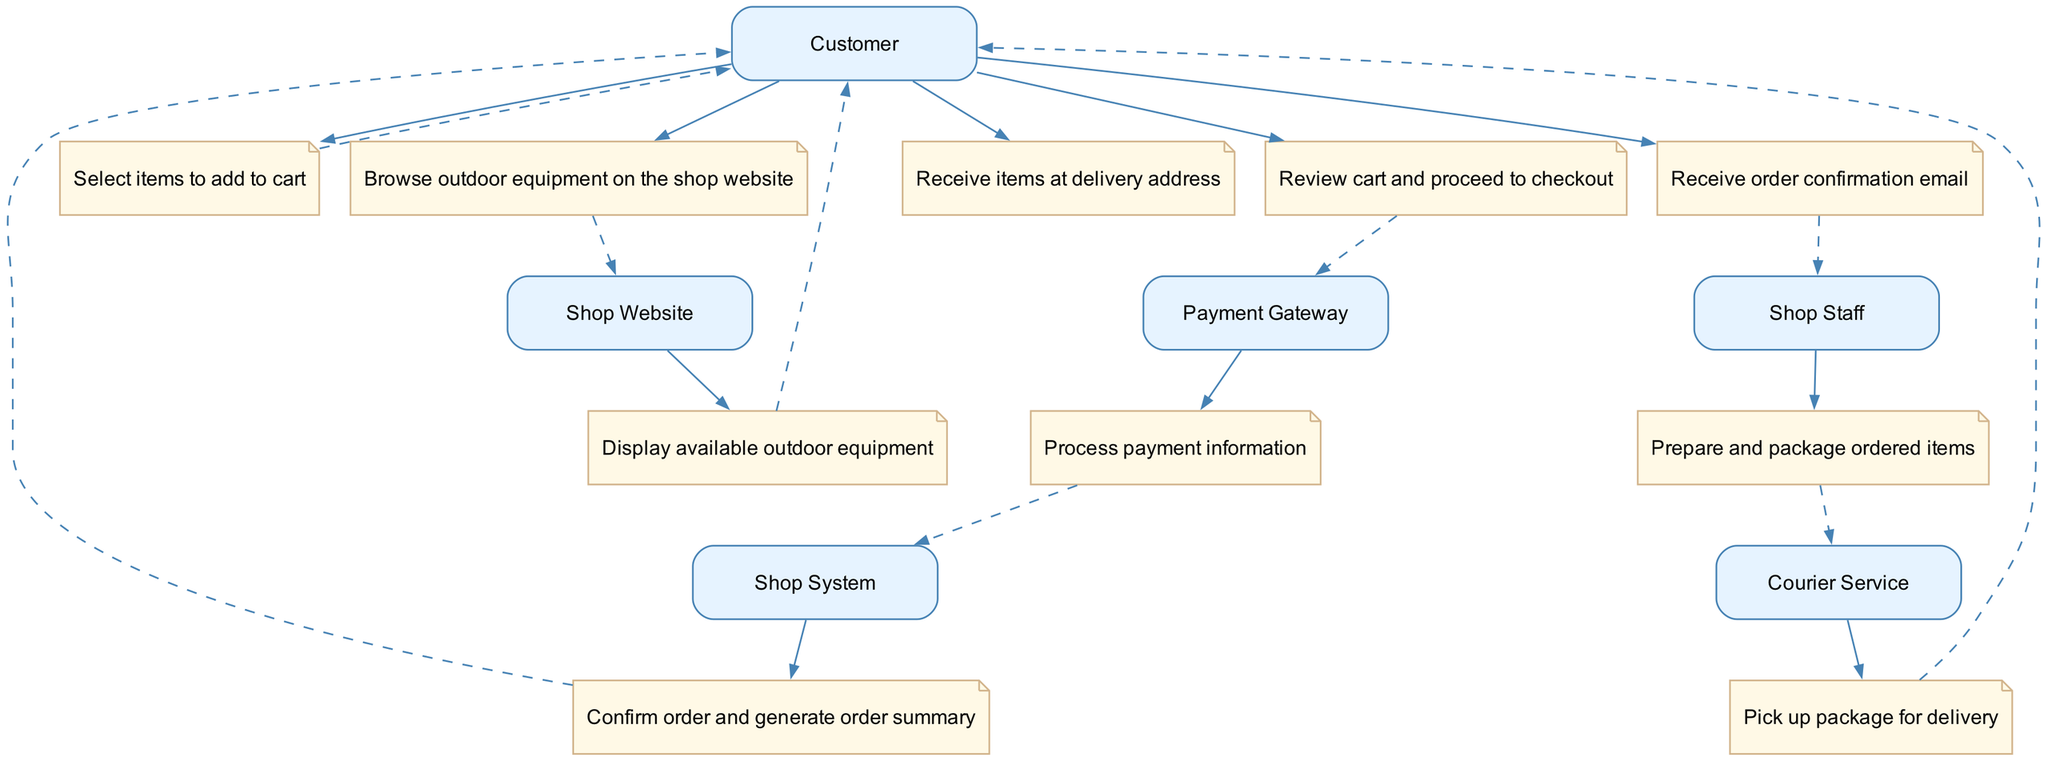What is the first action taken by the customer? The first action listed in the sequence diagram is "Browse outdoor equipment on the shop website," which indicates the initiation of the customer interaction with the shop's online platform.
Answer: Browse outdoor equipment on the shop website How many actors are involved in the process? By analyzing the diagram, I can see that there are five distinct actors: Customer, Shop Website, Payment Gateway, Shop Staff, and Courier Service. Therefore, the total number of actors is five.
Answer: Five What action does the shop system take after payment is processed? According to the sequence of actions, after the payment information is processed by the Payment Gateway, the next action performed is by the Shop System, which is to "Confirm order and generate order summary."
Answer: Confirm order and generate order summary Which actor prepares and packages the ordered items? The sequence diagram explicitly shows that the "Shop Staff" is responsible for preparing and packaging the ordered items, as indicated in the action following the order confirmation.
Answer: Shop Staff What is the final action taken by the customer in the sequence? The diagram indicates that the last action taken by the Customer is "Receive items at delivery address," summarizing the complete process from order to delivery.
Answer: Receive items at delivery address Who is responsible for delivering the package? The diagram specifies the role of the "Courier Service," indicating that their responsibility follows the preparation of the package by the Shop Staff, and they handle the delivery.
Answer: Courier Service How many actions are performed by the customer throughout the process? By reviewing the sequence elements, the Customer performs three actions: "Browse outdoor equipment on the shop website," "Select items to add to cart," and "Receive items at delivery address." The total count of distinct actions is three.
Answer: Three Which actor does the Customer interact with immediately after reviewing the cart? After the Customer reviews the cart, the next immediate action connects to the Payment Gateway, indicating that this is the actor they interact with for processing payment information.
Answer: Payment Gateway What connects the Shop System's action to the customer receiving confirmation? The connection is through a structured flow where the Shop System confirms the order and generates an order summary, leading directly to the action where the customer receives an order confirmation email.
Answer: Order summary 